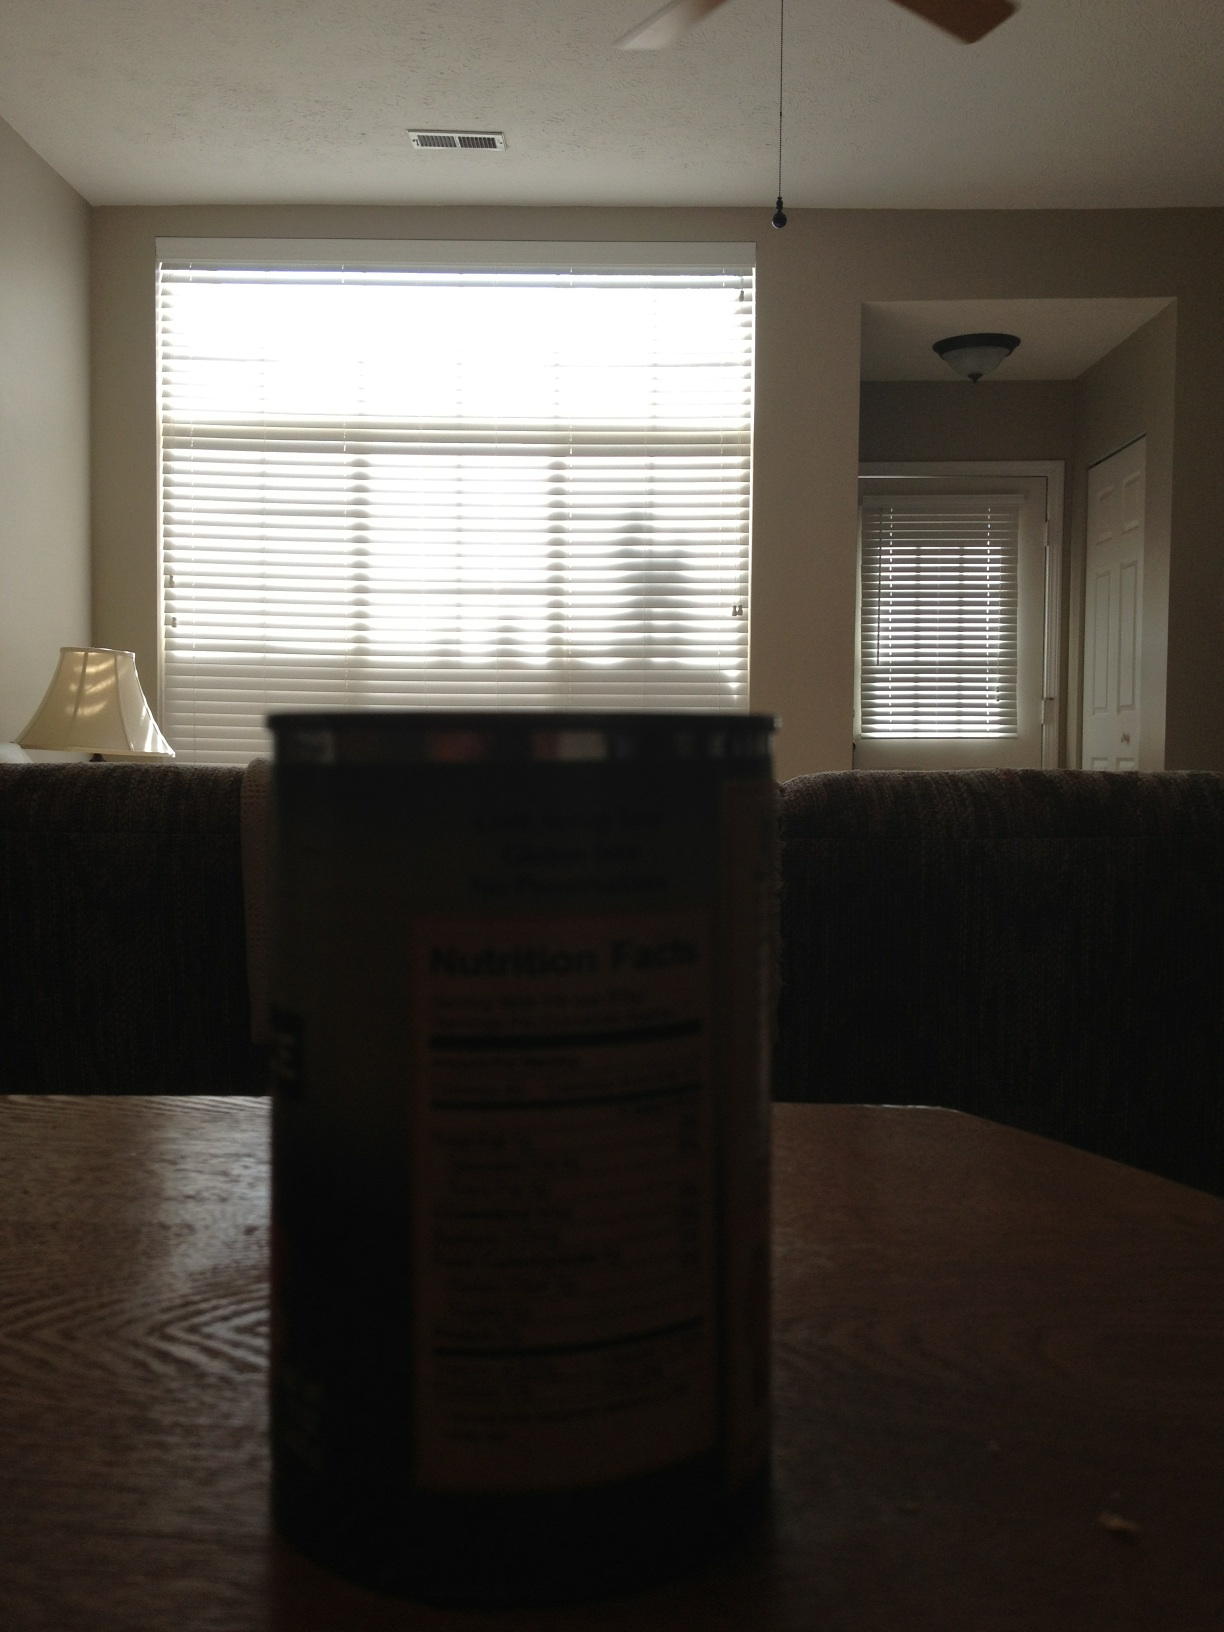What items can you identify in this room? In the room, there is a can on the table in the foreground and a lamp on a side table near the couch. The blinds on the window are drawn, allowing diffused light to fill the room. 